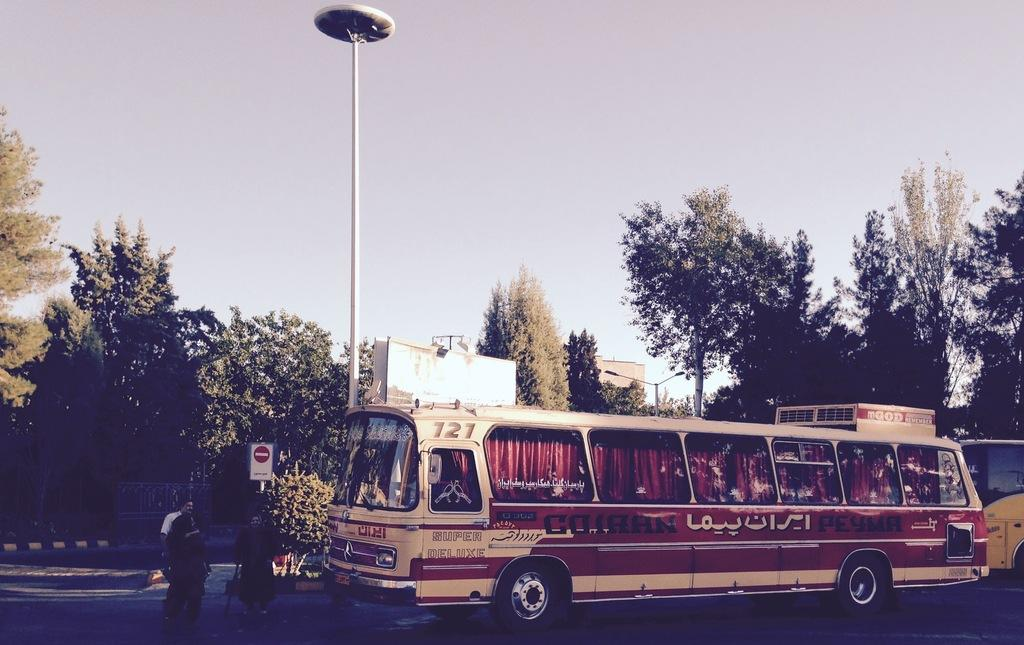<image>
Provide a brief description of the given image. A tan and brown bus sitting at a street corner with Arabic writing on it. 